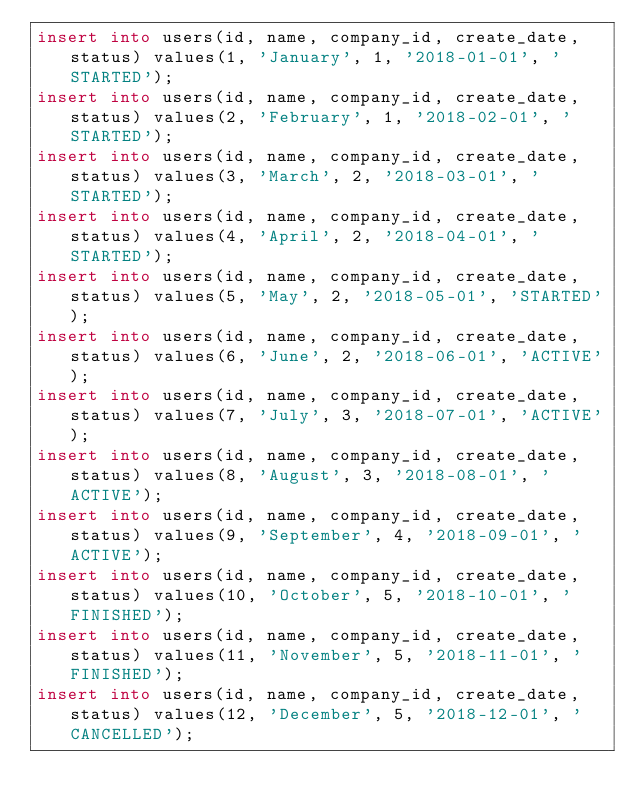<code> <loc_0><loc_0><loc_500><loc_500><_SQL_>insert into users(id, name, company_id, create_date, status) values(1, 'January', 1, '2018-01-01', 'STARTED');
insert into users(id, name, company_id, create_date, status) values(2, 'February', 1, '2018-02-01', 'STARTED');
insert into users(id, name, company_id, create_date, status) values(3, 'March', 2, '2018-03-01', 'STARTED');
insert into users(id, name, company_id, create_date, status) values(4, 'April', 2, '2018-04-01', 'STARTED');
insert into users(id, name, company_id, create_date, status) values(5, 'May', 2, '2018-05-01', 'STARTED');
insert into users(id, name, company_id, create_date, status) values(6, 'June', 2, '2018-06-01', 'ACTIVE');
insert into users(id, name, company_id, create_date, status) values(7, 'July', 3, '2018-07-01', 'ACTIVE');
insert into users(id, name, company_id, create_date, status) values(8, 'August', 3, '2018-08-01', 'ACTIVE');
insert into users(id, name, company_id, create_date, status) values(9, 'September', 4, '2018-09-01', 'ACTIVE');
insert into users(id, name, company_id, create_date, status) values(10, 'October', 5, '2018-10-01', 'FINISHED');
insert into users(id, name, company_id, create_date, status) values(11, 'November', 5, '2018-11-01', 'FINISHED');
insert into users(id, name, company_id, create_date, status) values(12, 'December', 5, '2018-12-01', 'CANCELLED');
</code> 